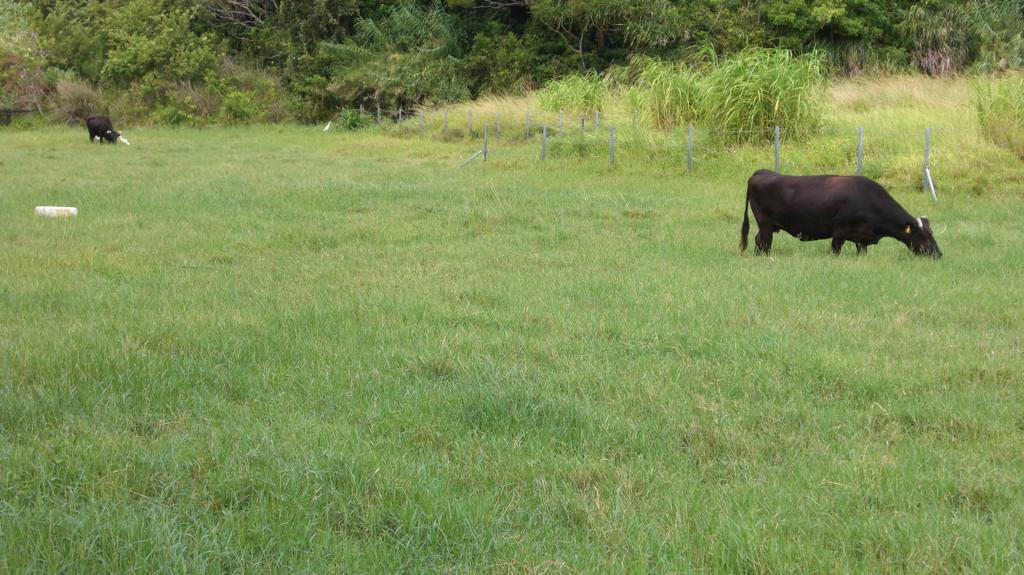Can you describe this image briefly? In this image we can see grass on the ground. There are cows. Also there are poles. In the background there are trees. 